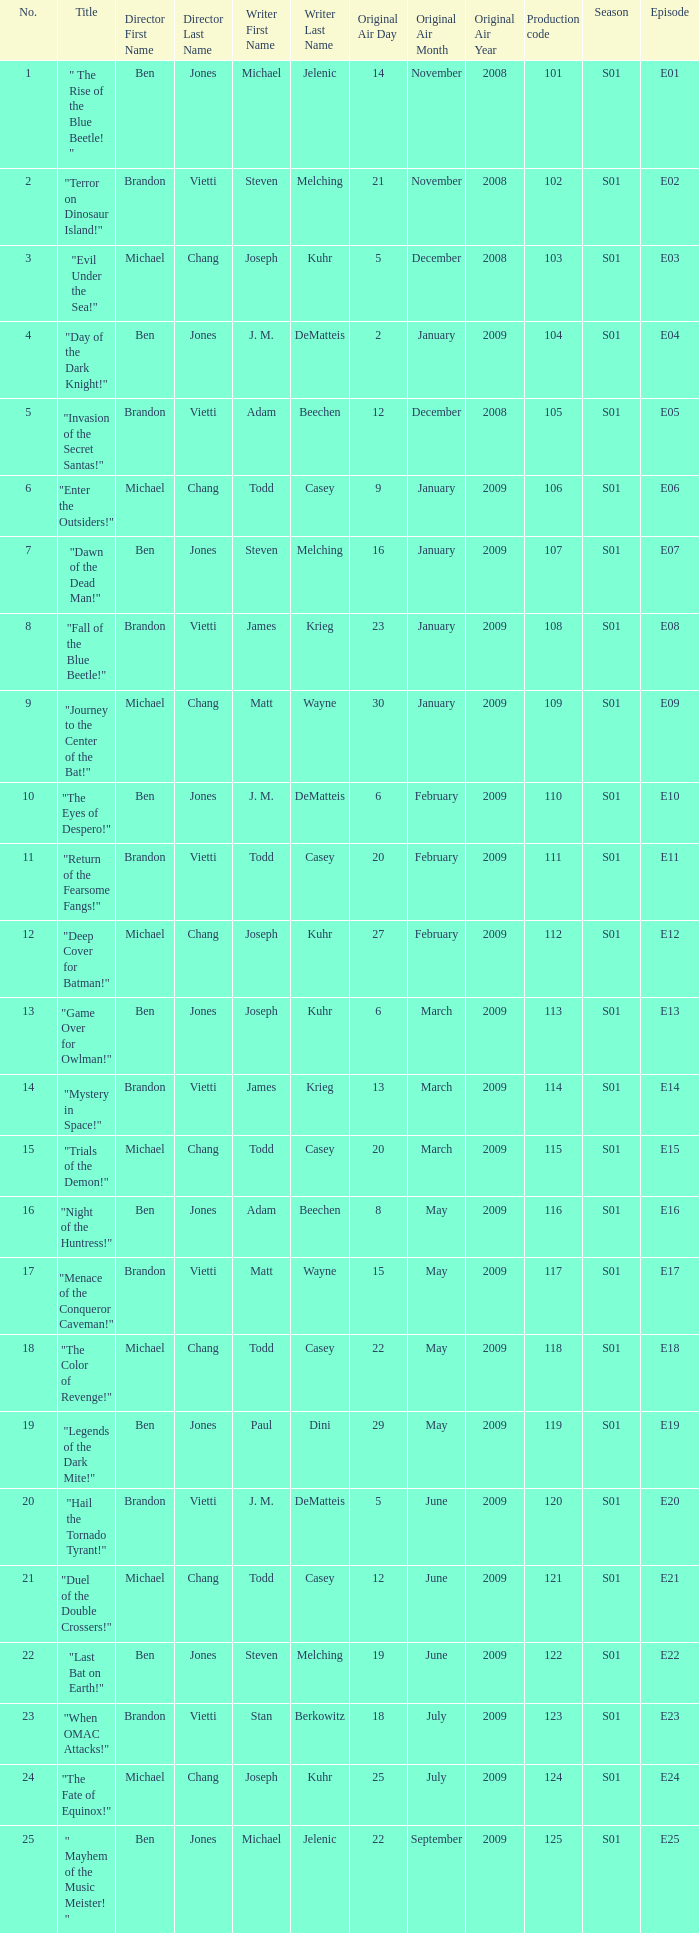Who wrote s01e06 Todd Casey. 